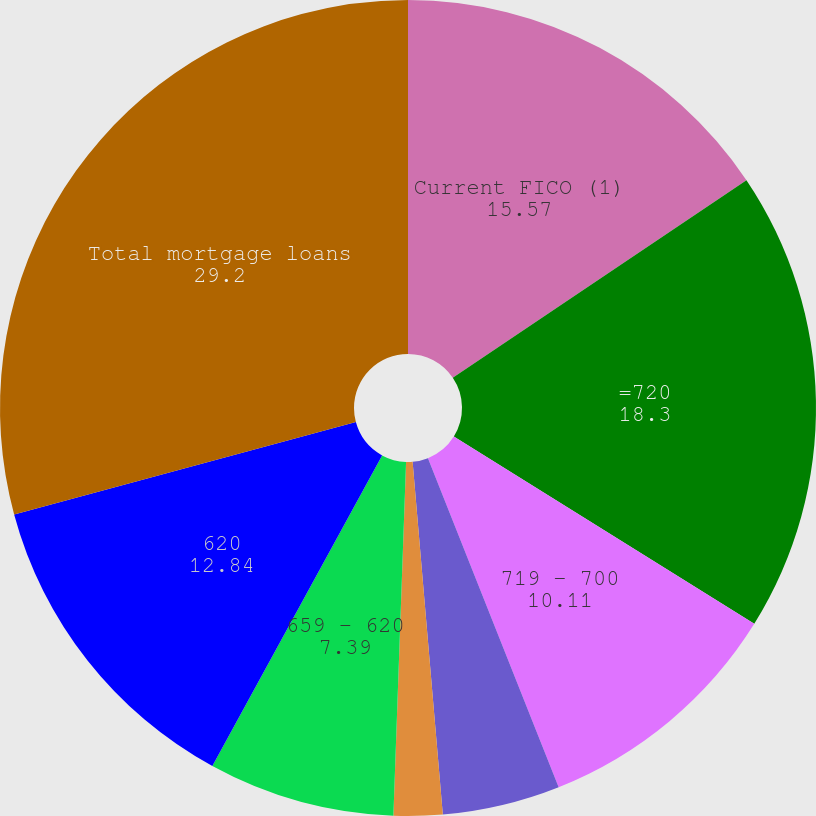Convert chart to OTSL. <chart><loc_0><loc_0><loc_500><loc_500><pie_chart><fcel>Current FICO (1)<fcel>=720<fcel>719 - 700<fcel>699 - 680<fcel>679 - 660<fcel>659 - 620<fcel>620<fcel>Total mortgage loans<nl><fcel>15.57%<fcel>18.3%<fcel>10.11%<fcel>4.66%<fcel>1.93%<fcel>7.39%<fcel>12.84%<fcel>29.2%<nl></chart> 